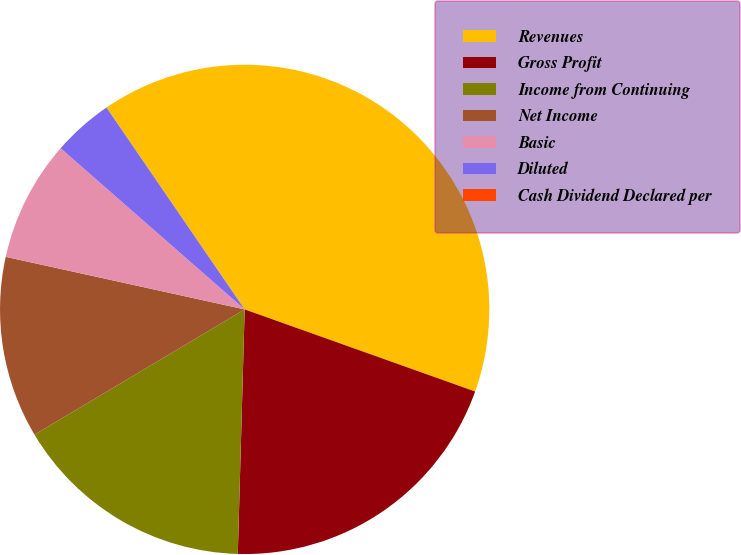Convert chart. <chart><loc_0><loc_0><loc_500><loc_500><pie_chart><fcel>Revenues<fcel>Gross Profit<fcel>Income from Continuing<fcel>Net Income<fcel>Basic<fcel>Diluted<fcel>Cash Dividend Declared per<nl><fcel>40.0%<fcel>20.0%<fcel>16.0%<fcel>12.0%<fcel>8.0%<fcel>4.0%<fcel>0.0%<nl></chart> 